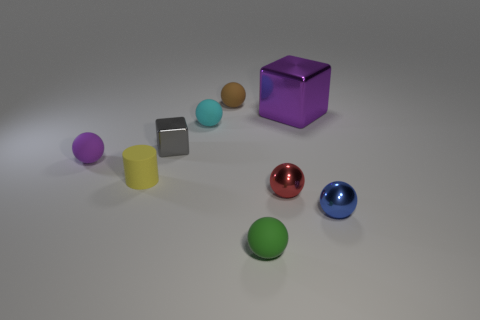Subtract 3 spheres. How many spheres are left? 3 Subtract all purple balls. How many balls are left? 5 Subtract all small matte spheres. How many spheres are left? 2 Subtract all blue balls. Subtract all green cylinders. How many balls are left? 5 Subtract all blocks. How many objects are left? 7 Subtract all big red matte cubes. Subtract all big metal blocks. How many objects are left? 8 Add 3 yellow rubber objects. How many yellow rubber objects are left? 4 Add 8 gray matte cubes. How many gray matte cubes exist? 8 Subtract 1 gray cubes. How many objects are left? 8 